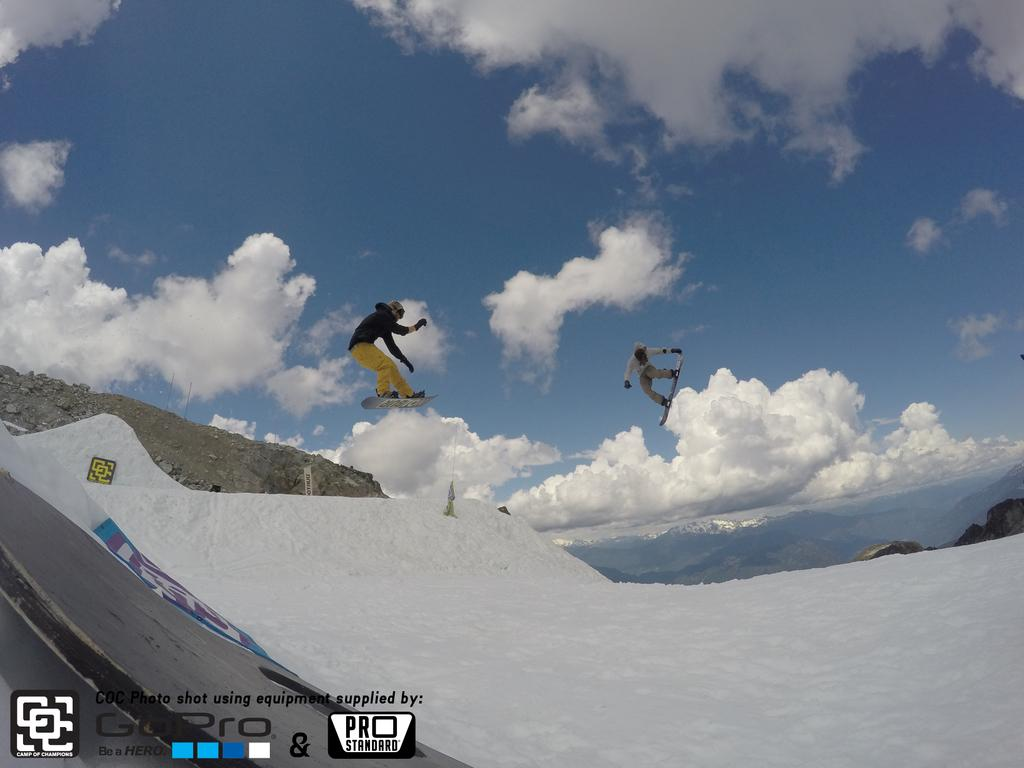How many people are in the foreground of the picture? There are two men in the foreground of the picture. What are the men doing in the picture? The men are skating in the picture. Are the men in contact with the ground in the image? No, the men are in the air in the image. What can be seen in the background of the picture? There is the sky in the background of the picture. What is the condition of the sky in the image? There are clouds in the sky in the image. What month is it in the image? The provided facts do not mention a specific month, so it cannot be determined from the image. Are there any ghosts visible in the image? There are no ghosts present in the image; it features two men skating in the air. 